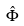<formula> <loc_0><loc_0><loc_500><loc_500>\hat { \Phi }</formula> 